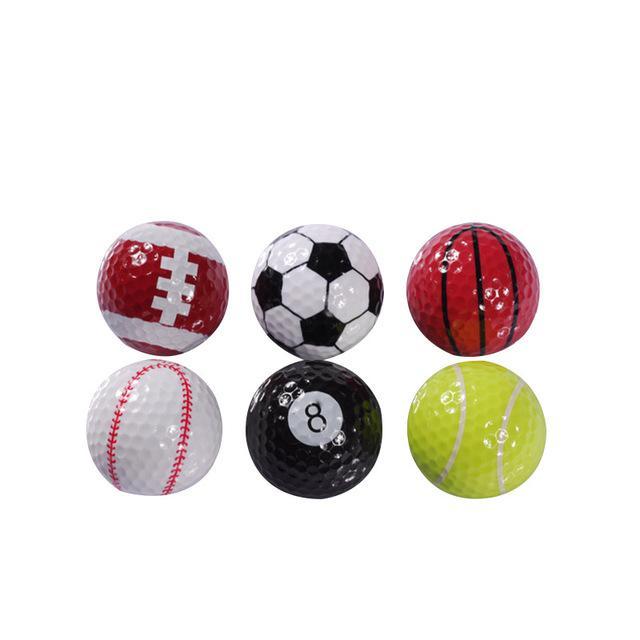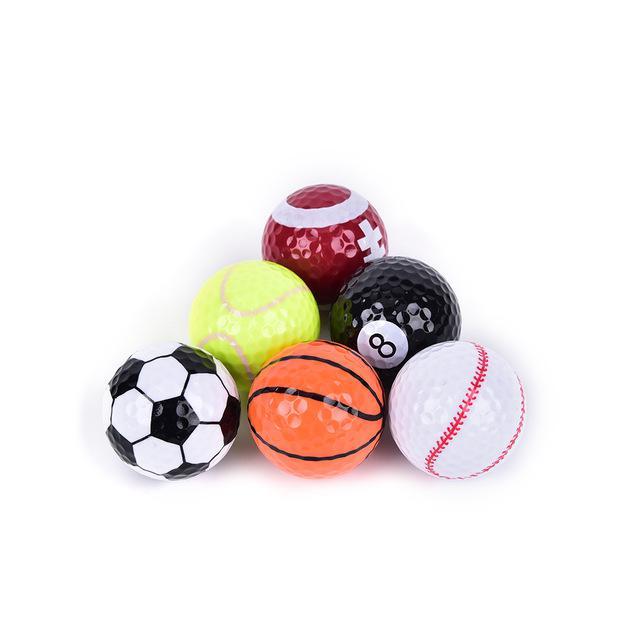The first image is the image on the left, the second image is the image on the right. Evaluate the accuracy of this statement regarding the images: "Two of the soccer balls are pink.". Is it true? Answer yes or no. No. The first image is the image on the left, the second image is the image on the right. Considering the images on both sides, is "There are more than 3 balls painted like soccer balls, and there are no numbers on any of them." valid? Answer yes or no. No. 